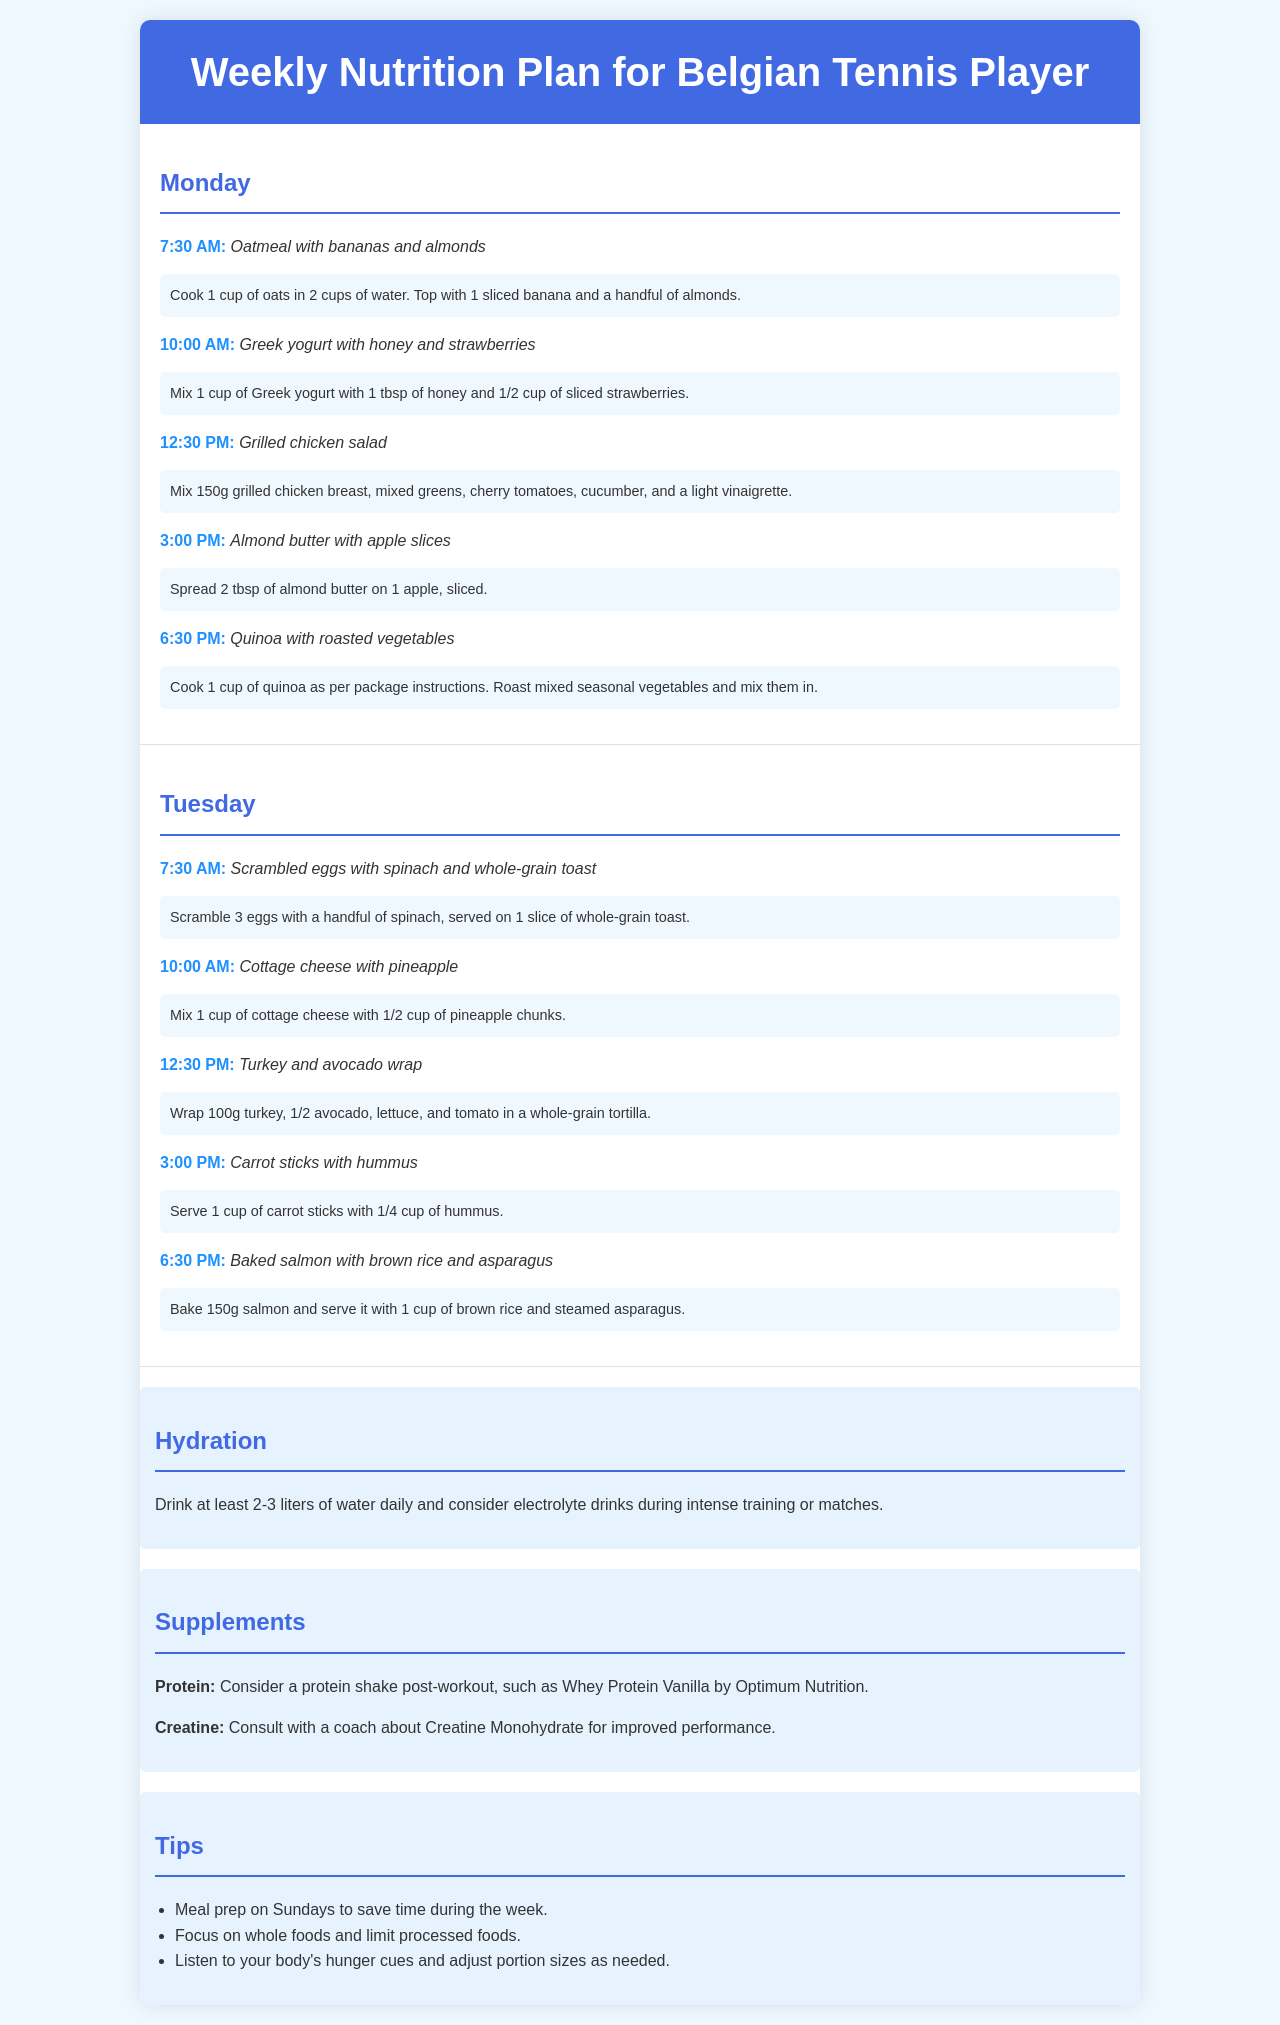What is the first meal on Monday? The first meal listed on Monday is oatmeal with bananas and almonds, which is mentioned at 7:30 AM.
Answer: Oatmeal with bananas and almonds How many liters of water should be consumed daily? The hydration section specifies drinking at least 2-3 liters of water daily.
Answer: 2-3 liters What time is the meal for Greek yogurt on Tuesday? The meal for Greek yogurt on Tuesday is scheduled at 10:00 AM.
Answer: 10:00 AM What is one of the supplements recommended for post-workout? The document mentions considering a protein shake post-workout, specifically Whey Protein Vanilla by Optimum Nutrition.
Answer: Whey Protein Vanilla How many grams of turkey are used in the Tuesday wrap? The Turkey and avocado wrap on Tuesday specifies using 100g turkey.
Answer: 100g What is the main protein source in the Tuesday dinner? The Tuesday dinner features baked salmon, indicating the main protein source for that meal.
Answer: Baked salmon What should be listened to regarding hunger? The tips section advises to listen to your body's hunger cues.
Answer: Body's hunger cues What food type does the document suggest focusing on? The tips section recommends focusing on whole foods and limiting processed foods.
Answer: Whole foods 